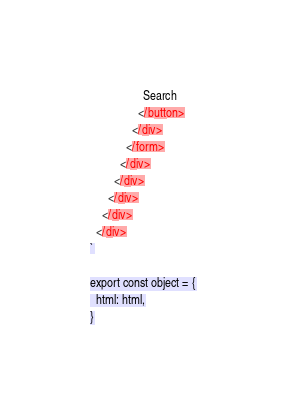Convert code to text. <code><loc_0><loc_0><loc_500><loc_500><_JavaScript_>                  Search
                </button>
              </div>
            </form>
          </div>
        </div>
      </div>
    </div>
  </div>
`

export const object = {
  html: html,
}
</code> 